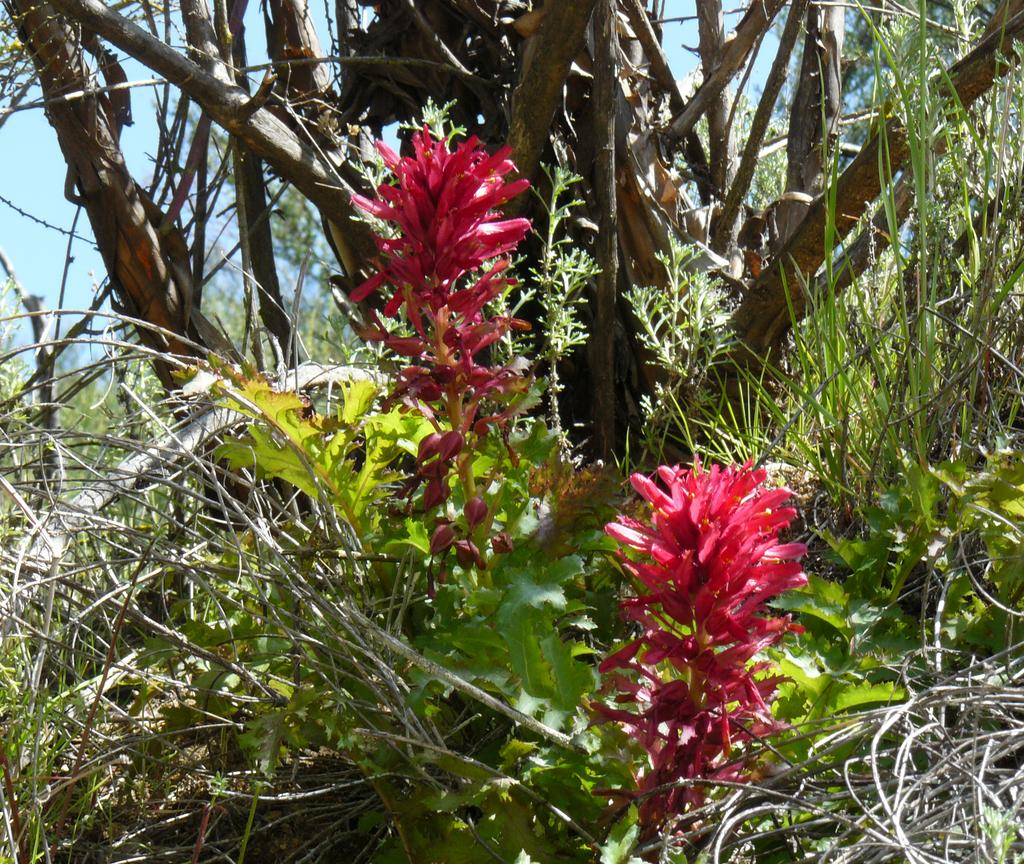What type of vegetation can be seen in the image? There are plants, trees, and grass in the image. What part of the natural environment is visible in the image? The sky is visible in the image. Can you see any insurance policies floating in the ocean in the image? There is no ocean or insurance policies present in the image. 